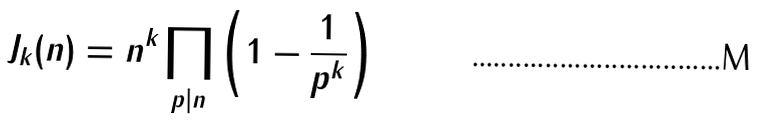Convert formula to latex. <formula><loc_0><loc_0><loc_500><loc_500>J _ { k } ( n ) = n ^ { k } \prod _ { p | n } \left ( 1 - \frac { 1 } { p ^ { k } } \right )</formula> 